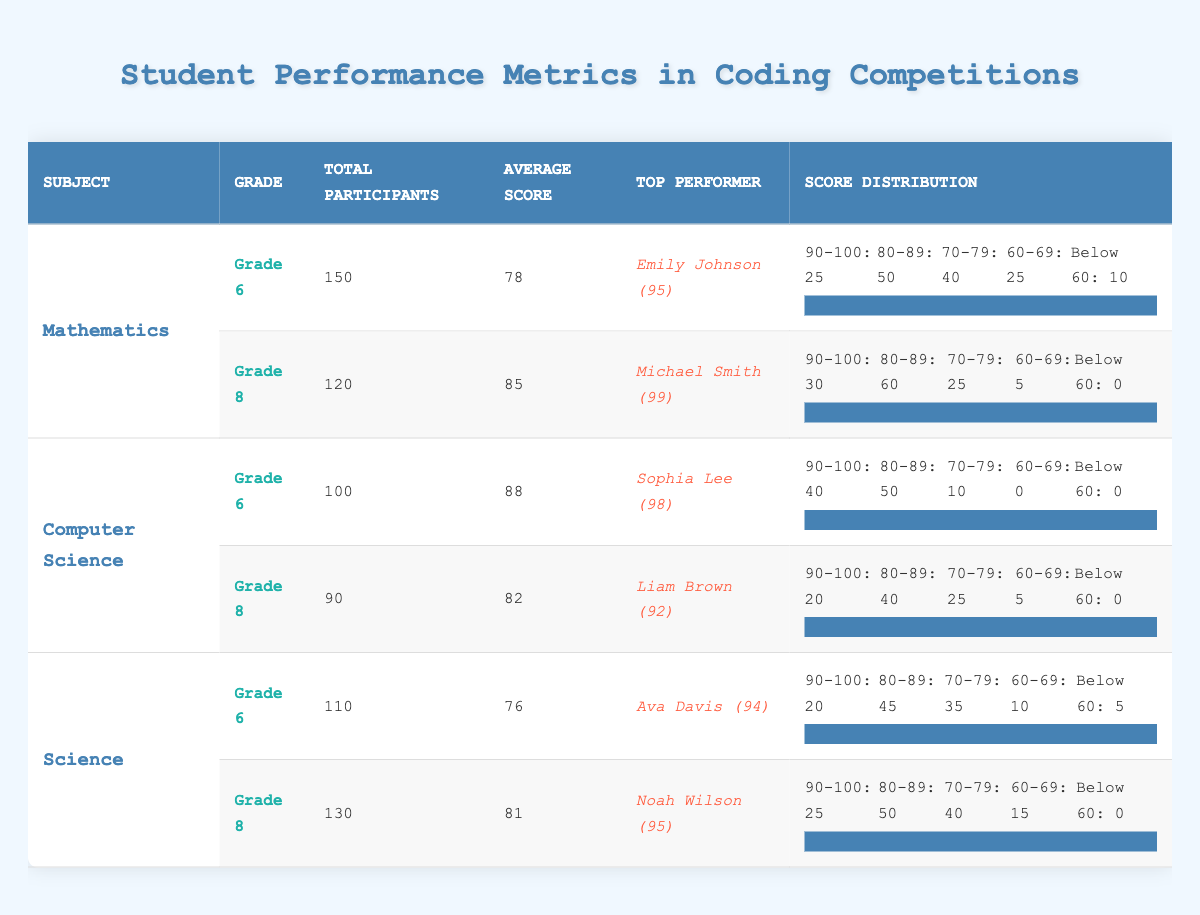What is the highest average score among the subjects for Grade 8? The average scores for Grade 8 are: Mathematics (85), Computer Science (82), and Science (81). The highest score is Mathematics at 85.
Answer: 85 What is the total number of participants in Grade 6 for Mathematics? Referring to the table, Mathematics Grade 6 has a total of 150 participants.
Answer: 150 Did more students score between 80-89 in Computer Science for Grade 6 or Grade 8? In Computer Science Grade 6, 50 students scored between 80-89, while in Grade 8, 40 students scored in that range. Thus, Grade 6 has more students.
Answer: Yes What is the total number of participants across all subjects for Grade 6? The total participants for Grade 6 are: Mathematics (150), Computer Science (100), and Science (110). Summing these gives 150 + 100 + 110 = 360 participants for Grade 6.
Answer: 360 Which subject had the lowest average score in Grade 6? The average scores for Grade 6 are: Mathematics (78), Computer Science (88), and Science (76). The lowest average score is in Science at 76.
Answer: Science How many students scored below 60 in Science for Grade 6? The score distribution for Science Grade 6 shows that 5 students scored below 60.
Answer: 5 What is the difference between the top scores of the top performers in Mathematics Grade 8 and Science Grade 8? The top score in Mathematics Grade 8 is 99 (by Michael Smith) and the top score in Science Grade 8 is 95 (by Noah Wilson). The difference is 99 - 95 = 4.
Answer: 4 Is the average score for Grade 8 in Mathematics higher than that of Science? The average scores for Grade 8 are Mathematics (85) and Science (81). Since 85 is greater than 81, the average score for Mathematics Grade 8 is higher than that for Science.
Answer: Yes What percentage of participants in Grade 6 for Computer Science scored between 90-100? In Grade 6 for Computer Science, 40 students scored between 90-100 out of 100 total participants. Thus, the percentage is (40/100) * 100 = 40%.
Answer: 40% 